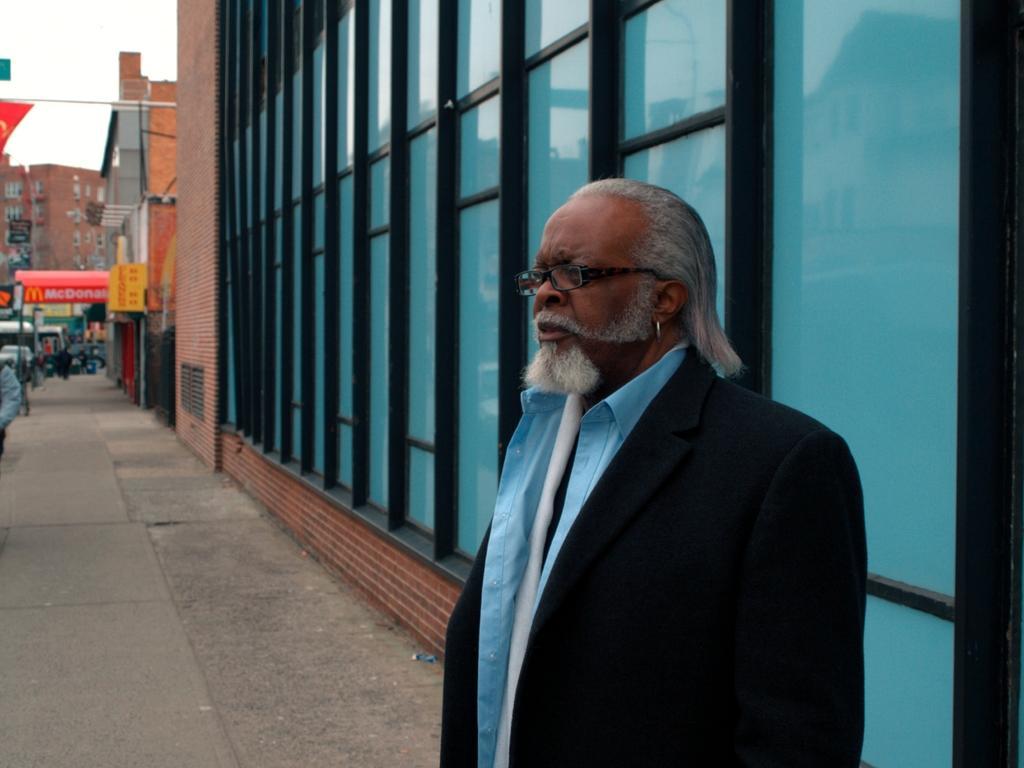Describe this image in one or two sentences. In this image, we can see buildings. There is a person at the bottom of the image wearing clothes. 